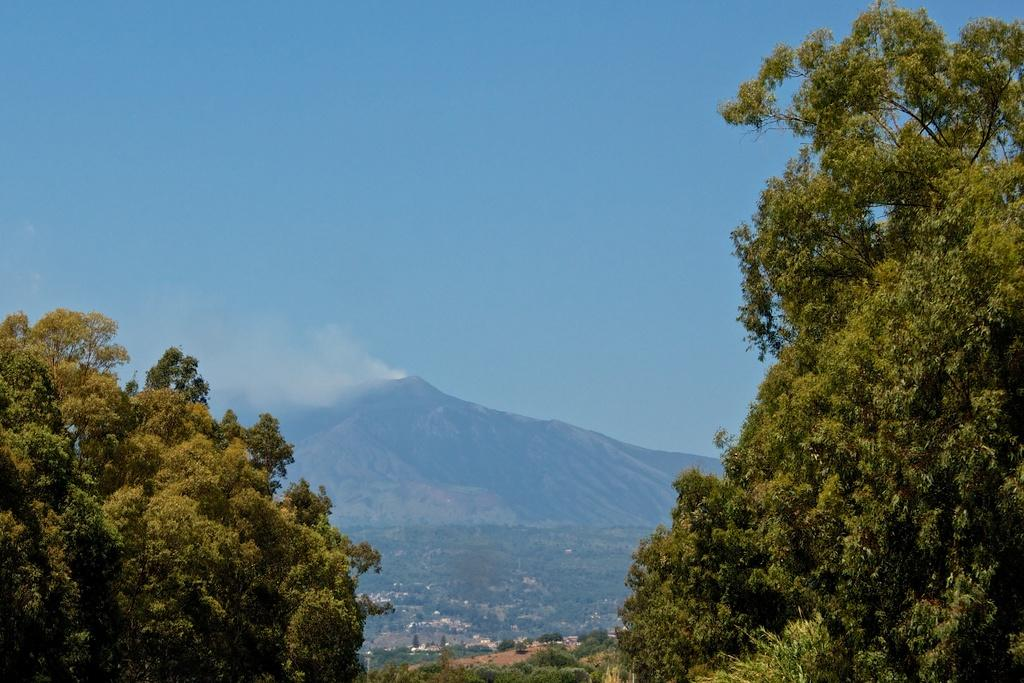What type of vegetation can be seen in the image? There are trees in the image. What is visible in the background of the image? There is a hill and smoke visible in the background of the image. What is the color of the sky in the image? The sky is blue in color. What type of juice is being served in the image? There is no juice present in the image. What type of leather is visible on the trees in the image? There is no leather present on the trees in the image. 